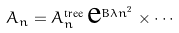Convert formula to latex. <formula><loc_0><loc_0><loc_500><loc_500>A _ { n } = A _ { n } ^ { \text {tree} } \, \text {e} ^ { B \lambda n ^ { 2 } } \times \cdots</formula> 